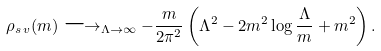Convert formula to latex. <formula><loc_0><loc_0><loc_500><loc_500>\rho _ { s \, v } ( m ) \longrightarrow _ { \Lambda \to \infty } - \frac { m } { 2 \pi ^ { 2 } } \left ( \Lambda ^ { 2 } - 2 m ^ { 2 } \log \frac { \Lambda } { m } + m ^ { 2 } \right ) .</formula> 